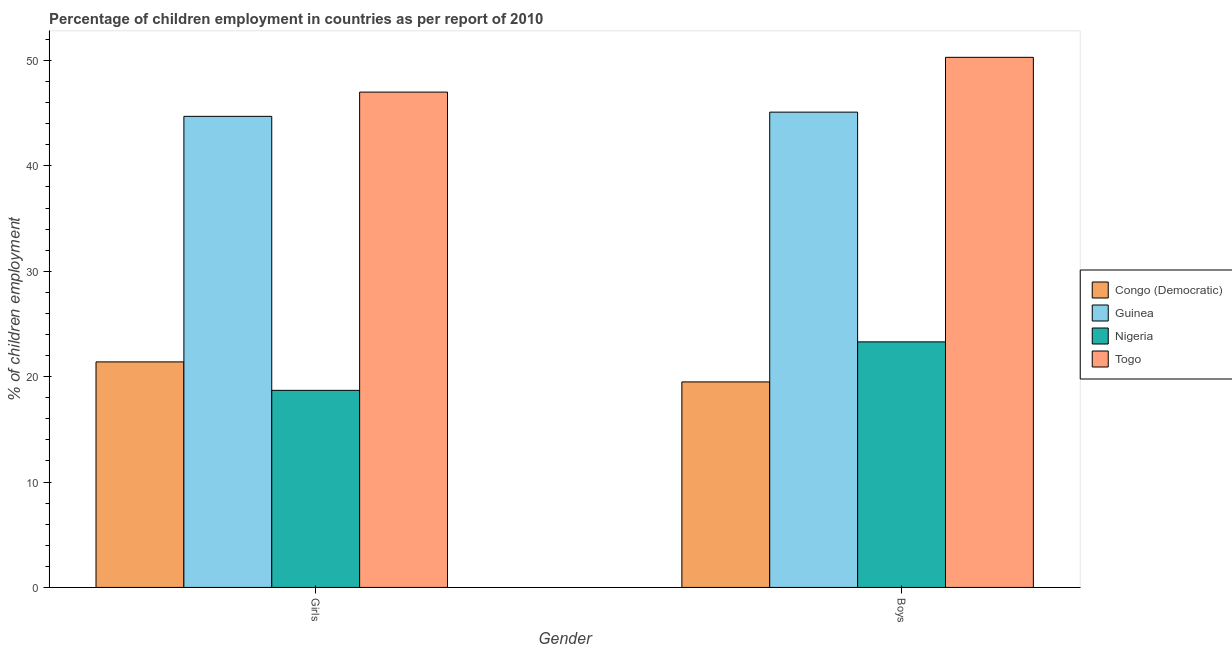How many different coloured bars are there?
Offer a very short reply. 4. How many groups of bars are there?
Provide a short and direct response. 2. How many bars are there on the 1st tick from the left?
Offer a terse response. 4. What is the label of the 2nd group of bars from the left?
Keep it short and to the point. Boys. What is the percentage of employed boys in Nigeria?
Make the answer very short. 23.3. In which country was the percentage of employed boys maximum?
Keep it short and to the point. Togo. In which country was the percentage of employed boys minimum?
Make the answer very short. Congo (Democratic). What is the total percentage of employed boys in the graph?
Provide a succinct answer. 138.2. What is the difference between the percentage of employed girls in Nigeria and that in Togo?
Offer a terse response. -28.3. What is the difference between the percentage of employed boys in Nigeria and the percentage of employed girls in Congo (Democratic)?
Offer a terse response. 1.9. What is the average percentage of employed boys per country?
Keep it short and to the point. 34.55. What is the difference between the percentage of employed girls and percentage of employed boys in Togo?
Offer a terse response. -3.3. What is the ratio of the percentage of employed girls in Guinea to that in Congo (Democratic)?
Your answer should be very brief. 2.09. Is the percentage of employed girls in Guinea less than that in Togo?
Offer a very short reply. Yes. In how many countries, is the percentage of employed boys greater than the average percentage of employed boys taken over all countries?
Give a very brief answer. 2. What does the 4th bar from the left in Boys represents?
Provide a succinct answer. Togo. What does the 3rd bar from the right in Boys represents?
Your response must be concise. Guinea. How many bars are there?
Provide a succinct answer. 8. Are all the bars in the graph horizontal?
Your answer should be very brief. No. How many countries are there in the graph?
Your answer should be compact. 4. What is the difference between two consecutive major ticks on the Y-axis?
Offer a very short reply. 10. Does the graph contain any zero values?
Offer a terse response. No. Does the graph contain grids?
Provide a short and direct response. No. How many legend labels are there?
Give a very brief answer. 4. What is the title of the graph?
Make the answer very short. Percentage of children employment in countries as per report of 2010. Does "Congo (Democratic)" appear as one of the legend labels in the graph?
Give a very brief answer. Yes. What is the label or title of the Y-axis?
Ensure brevity in your answer.  % of children employment. What is the % of children employment of Congo (Democratic) in Girls?
Your answer should be very brief. 21.4. What is the % of children employment in Guinea in Girls?
Offer a terse response. 44.7. What is the % of children employment in Togo in Girls?
Your answer should be compact. 47. What is the % of children employment in Guinea in Boys?
Make the answer very short. 45.1. What is the % of children employment of Nigeria in Boys?
Ensure brevity in your answer.  23.3. What is the % of children employment in Togo in Boys?
Keep it short and to the point. 50.3. Across all Gender, what is the maximum % of children employment of Congo (Democratic)?
Provide a succinct answer. 21.4. Across all Gender, what is the maximum % of children employment in Guinea?
Give a very brief answer. 45.1. Across all Gender, what is the maximum % of children employment of Nigeria?
Your answer should be very brief. 23.3. Across all Gender, what is the maximum % of children employment in Togo?
Offer a very short reply. 50.3. Across all Gender, what is the minimum % of children employment in Congo (Democratic)?
Offer a very short reply. 19.5. Across all Gender, what is the minimum % of children employment of Guinea?
Provide a short and direct response. 44.7. Across all Gender, what is the minimum % of children employment in Togo?
Provide a succinct answer. 47. What is the total % of children employment in Congo (Democratic) in the graph?
Your answer should be compact. 40.9. What is the total % of children employment of Guinea in the graph?
Keep it short and to the point. 89.8. What is the total % of children employment of Togo in the graph?
Give a very brief answer. 97.3. What is the difference between the % of children employment of Congo (Democratic) in Girls and that in Boys?
Your response must be concise. 1.9. What is the difference between the % of children employment in Guinea in Girls and that in Boys?
Your response must be concise. -0.4. What is the difference between the % of children employment of Togo in Girls and that in Boys?
Provide a short and direct response. -3.3. What is the difference between the % of children employment in Congo (Democratic) in Girls and the % of children employment in Guinea in Boys?
Offer a very short reply. -23.7. What is the difference between the % of children employment in Congo (Democratic) in Girls and the % of children employment in Nigeria in Boys?
Provide a succinct answer. -1.9. What is the difference between the % of children employment in Congo (Democratic) in Girls and the % of children employment in Togo in Boys?
Provide a short and direct response. -28.9. What is the difference between the % of children employment in Guinea in Girls and the % of children employment in Nigeria in Boys?
Make the answer very short. 21.4. What is the difference between the % of children employment of Nigeria in Girls and the % of children employment of Togo in Boys?
Your answer should be compact. -31.6. What is the average % of children employment in Congo (Democratic) per Gender?
Your answer should be very brief. 20.45. What is the average % of children employment of Guinea per Gender?
Ensure brevity in your answer.  44.9. What is the average % of children employment in Nigeria per Gender?
Your answer should be very brief. 21. What is the average % of children employment of Togo per Gender?
Offer a very short reply. 48.65. What is the difference between the % of children employment of Congo (Democratic) and % of children employment of Guinea in Girls?
Ensure brevity in your answer.  -23.3. What is the difference between the % of children employment of Congo (Democratic) and % of children employment of Nigeria in Girls?
Give a very brief answer. 2.7. What is the difference between the % of children employment in Congo (Democratic) and % of children employment in Togo in Girls?
Keep it short and to the point. -25.6. What is the difference between the % of children employment in Guinea and % of children employment in Nigeria in Girls?
Give a very brief answer. 26. What is the difference between the % of children employment in Nigeria and % of children employment in Togo in Girls?
Provide a short and direct response. -28.3. What is the difference between the % of children employment in Congo (Democratic) and % of children employment in Guinea in Boys?
Keep it short and to the point. -25.6. What is the difference between the % of children employment in Congo (Democratic) and % of children employment in Togo in Boys?
Ensure brevity in your answer.  -30.8. What is the difference between the % of children employment of Guinea and % of children employment of Nigeria in Boys?
Offer a terse response. 21.8. What is the difference between the % of children employment in Nigeria and % of children employment in Togo in Boys?
Offer a very short reply. -27. What is the ratio of the % of children employment of Congo (Democratic) in Girls to that in Boys?
Your response must be concise. 1.1. What is the ratio of the % of children employment of Nigeria in Girls to that in Boys?
Your answer should be compact. 0.8. What is the ratio of the % of children employment of Togo in Girls to that in Boys?
Provide a short and direct response. 0.93. What is the difference between the highest and the second highest % of children employment of Congo (Democratic)?
Keep it short and to the point. 1.9. What is the difference between the highest and the second highest % of children employment in Nigeria?
Provide a succinct answer. 4.6. What is the difference between the highest and the lowest % of children employment in Togo?
Your response must be concise. 3.3. 